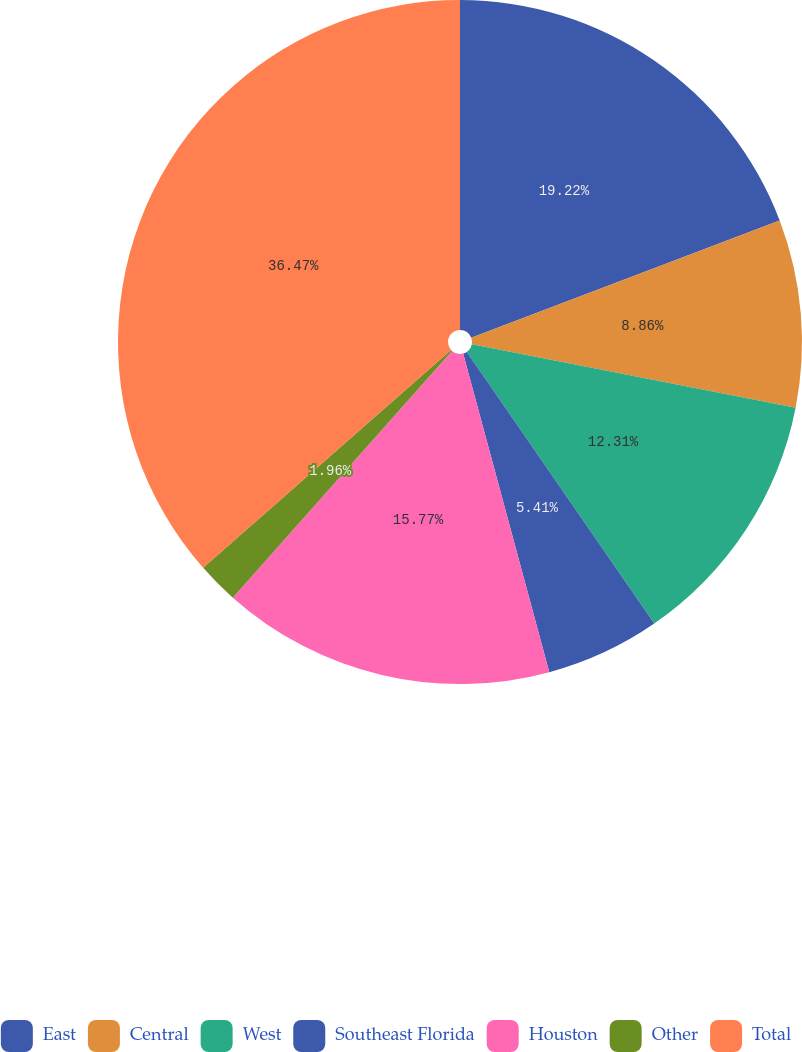Convert chart. <chart><loc_0><loc_0><loc_500><loc_500><pie_chart><fcel>East<fcel>Central<fcel>West<fcel>Southeast Florida<fcel>Houston<fcel>Other<fcel>Total<nl><fcel>19.22%<fcel>8.86%<fcel>12.31%<fcel>5.41%<fcel>15.77%<fcel>1.96%<fcel>36.48%<nl></chart> 